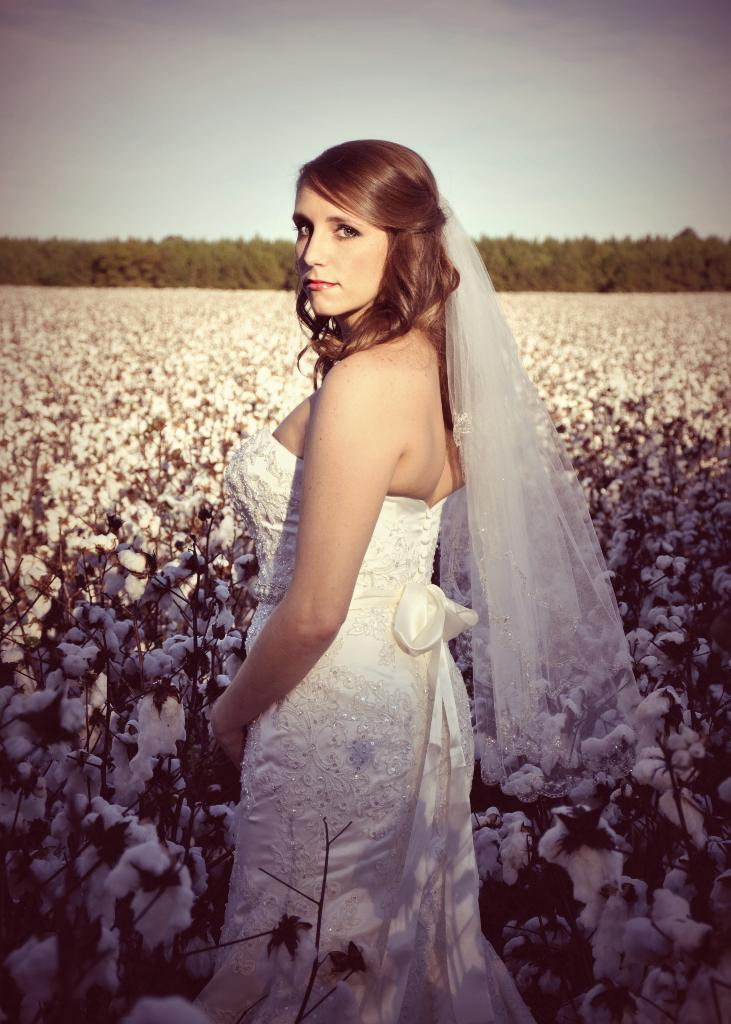Who is the main subject in the image? There is a woman in the image. Can you describe the woman's position in the image? The woman is standing in the front. What is the woman wearing in the image? The woman is wearing a white dress. What can be seen in the background of the image? There are flowers and trees in the background of the image. What type of pancake is being discussed by the committee in the image? There is no committee or pancake present in the image; it features a woman standing in front of flowers and trees. Can you tell me how the woman is using the brush in the image? There is no brush present in the image; the woman is simply standing in front of flowers and trees. 